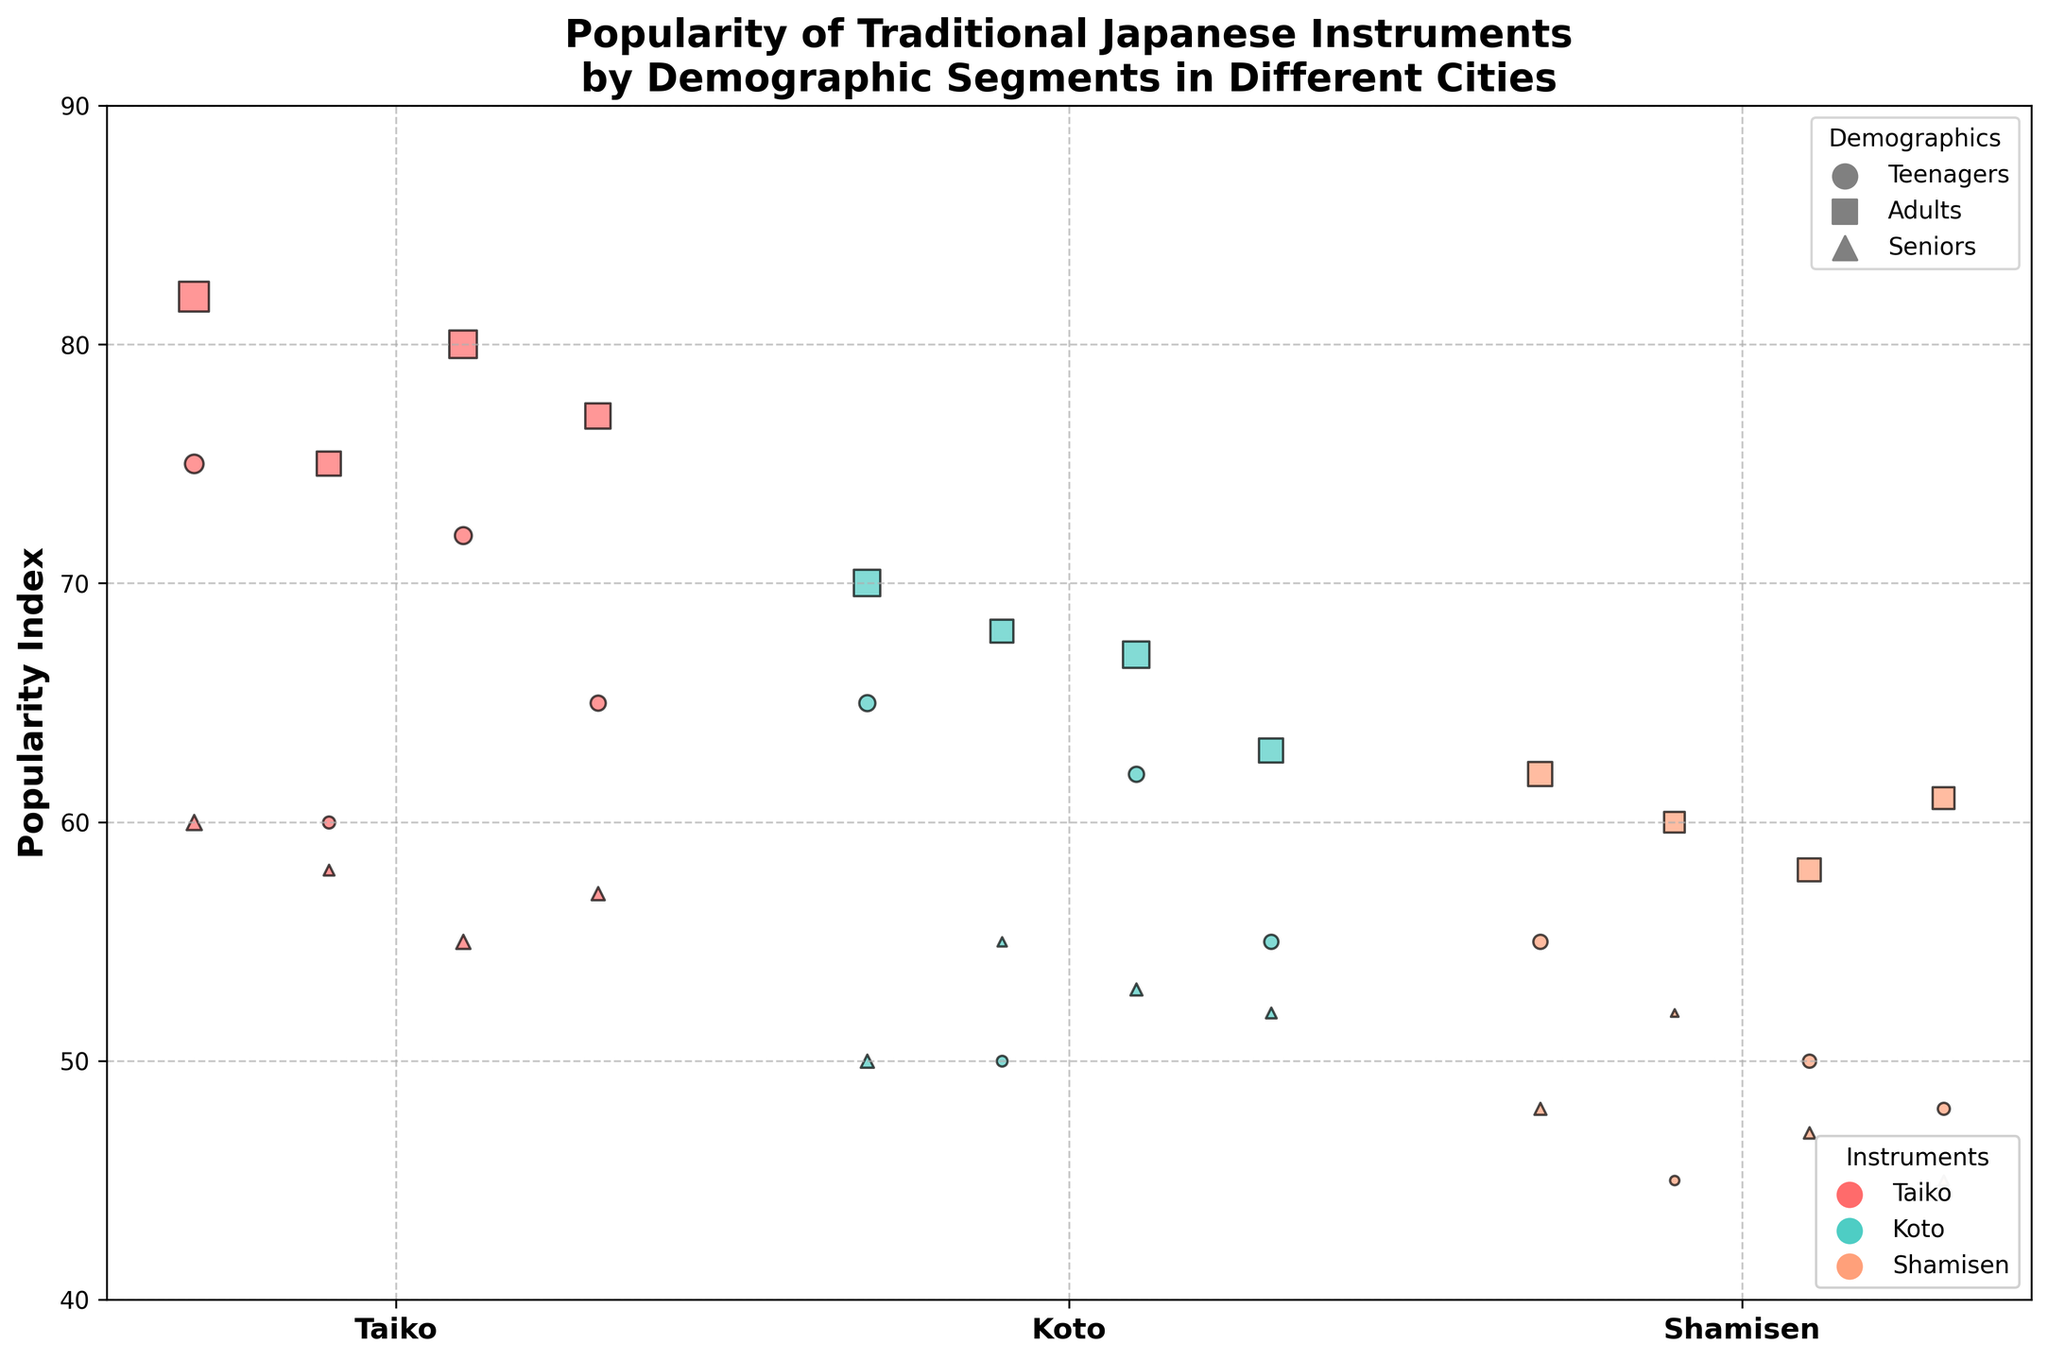1. What is the title of the chart? Look at the top of the chart where the title is usually placed.
Answer: Popularity of Traditional Japanese Instruments by Demographic Segments in Different Cities 2. Which instrument has the highest popularity index among adults in Tokyo? Locate the bubbles for Tokyo on the x-axis, then refer to the segment labeled 'Adults'. Compare the y-values (Popularity Index) of the bubbles corresponding to each instrument.
Answer: Taiko 3. How many demographic segments are represented in the chart? Identify the unique shapes used to differentiate demographic segments in the legend.
Answer: Three 4. Which city has the smallest number of practitioners for Shamisen among seniors? Find the 'Shamisen' label on the x-axis, and look for the bubbles representing 'Seniors' in each city. Compare the sizes of these bubbles.
Answer: Kyoto 5. What is the combined number of Koto practitioners in Kyoto and Osaka among teenagers? Locate the bubbles for teenagers in Kyoto and Osaka for Koto, and sum their sizes, given by the number of practitioners.
Answer: 400 (Kyoto) + 800 (Osaka) = 1200 6. Which demographic segment shows the lowest popularity index for Taiko in Nagoya? Locate Nagoya on the x-axis under the Taiko label and compare the y-values (Popularity Index) for all demographic bubbles.
Answer: Seniors 7. Compare the popularity index of Koto between adults in Osaka and adults in Kyoto. Which is higher? Identify and compare the y-values (Popularity Index) of the bubbles for adults in both cities under the Koto label.
Answer: Osaka 8. How is the popularity of Shamisen among seniors in the represented cities? Locate the bubbles for seniors in each city under the Shamisen label and compare their y-values (Popularity Index).
Answer: Tokyo: 48, Kyoto: 52, Osaka: 47, Nagoya: 45 9. For which instrument and city combination do teenagers have the highest popularity index? Identify the bubbles for teenagers at each city position on the x-axis and compare their y-values (Popularity Index) for each instrument.
Answer: Taiko in Tokyo 10. Are Taiko practitioners more numerous than Koto practitioners in adults across all cities? Compare the bubble sizes representing adults for Taiko and Koto in each city.
Answer: Yes 